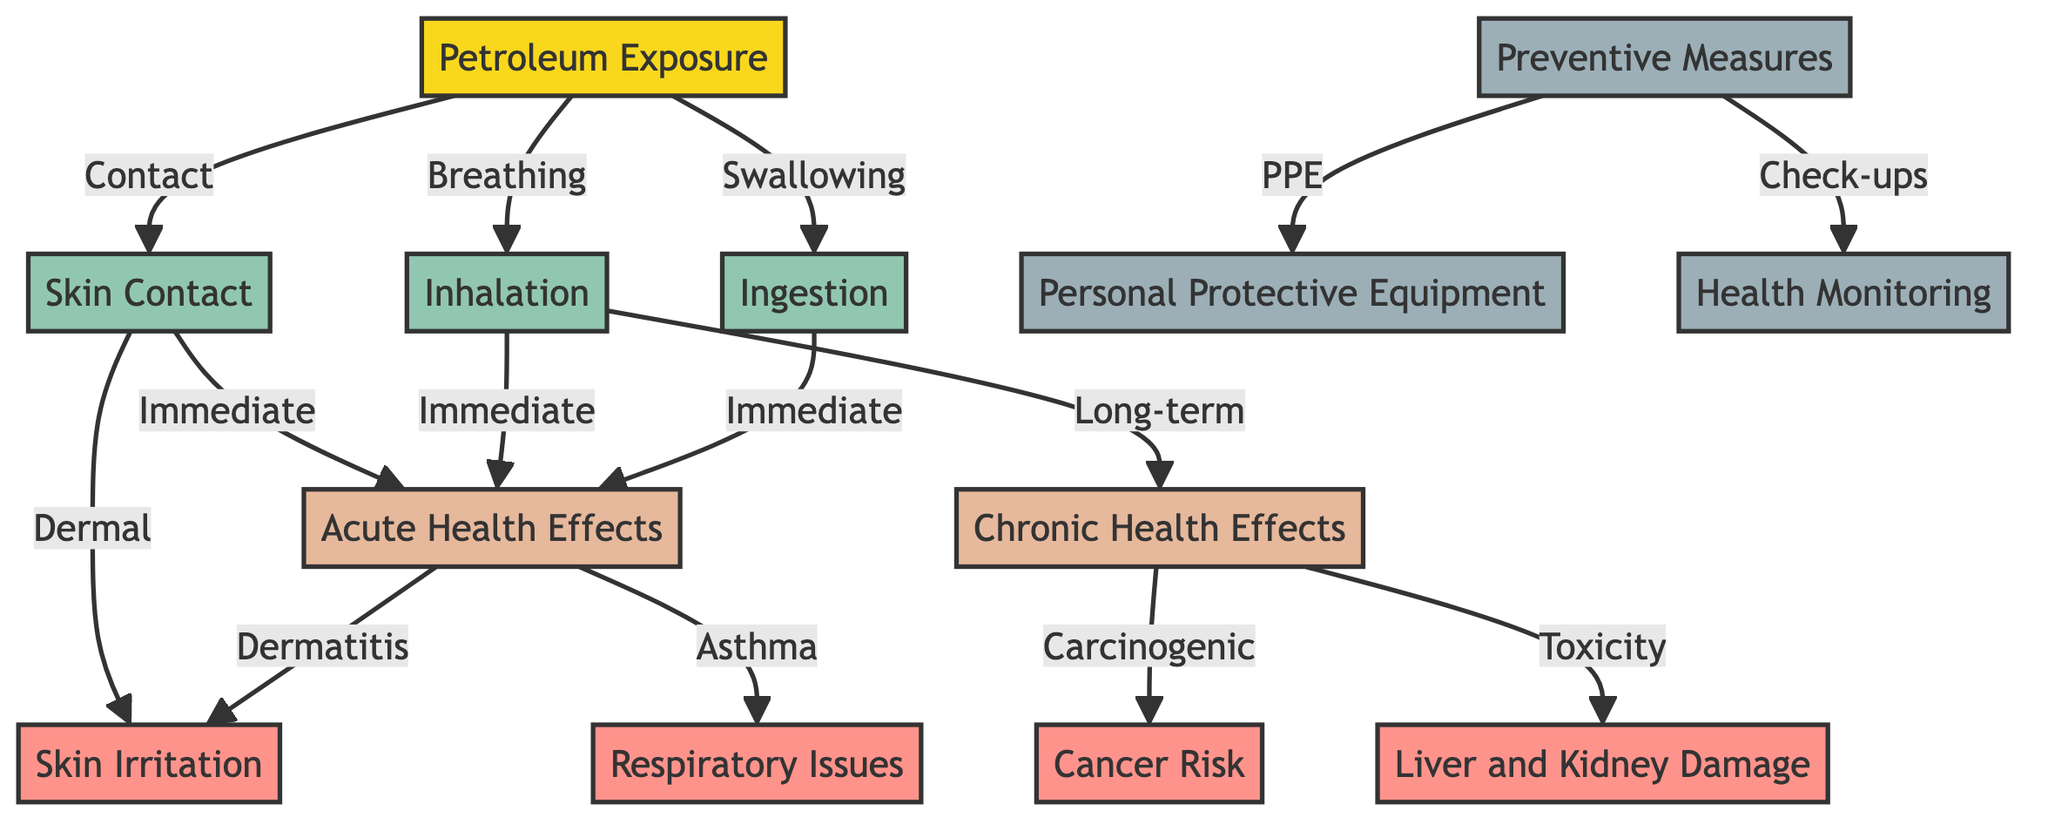What is the source of health impact in this diagram? The diagram begins with "Petroleum Exposure" as the initial node, identifying it as the primary factor affecting health.
Answer: Petroleum Exposure How many immediate acute health effects are listed? The diagram displays two immediate effects stemming from "Skin Contact," "Inhalation," and "Ingestion" leading to "Acute Health Effects." Each pathway has one immediate effect, counting them results in three acute health effects.
Answer: 3 What condition is associated with chronic health effects? The connected node "Chronic Health Effects" includes "Cancer Risk," which is identified as a long-term result of petroleum exposure.
Answer: Cancer Risk What preventive measure is highlighted in the diagram for health effects? The diagram emphasizes "Preventive Measures" which includes "Personal Protective Equipment" as one approach to mitigate health risks.
Answer: Personal Protective Equipment Which health conditions result from inhalation? The inhalation pathway directs towards "Immediate" effects leading to "Asthma," which is identified in the diagram as a respiratory issue.
Answer: Asthma Which node directly precedes "Respiratory Issues"? The diagram flow shows that "Inhalation" leads directly to "Respiratory Issues," making it the immediate precursor to this condition.
Answer: Inhalation How many nodes represent action steps to mitigate health impacts? There are three action nodes: "Preventive Measures," "Personal Protective Equipment," and "Health Monitoring," highlighting the steps to combat health effects from petroleum exposure.
Answer: 3 What is the connection between "Skin Contact" and dermal health effects? "Skin Contact" leads directly to "Acute Health Effects," which includes "Dermatitis," indicating that exposure causes immediate skin-related health problems.
Answer: Dermatitis What does "Ingestion" lead to in the context of health effects? The diagram shows that "Ingestion" can result in "Acute Health Effects," including the serious consequence of "Liver and Kidney Damage," linking ingestion directly to severe health issues.
Answer: Liver and Kidney Damage 